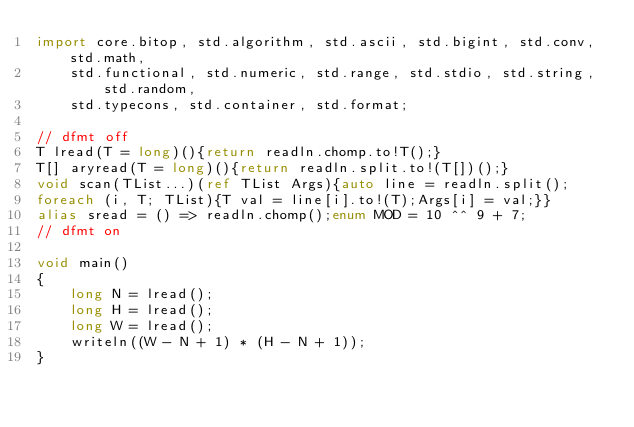<code> <loc_0><loc_0><loc_500><loc_500><_D_>import core.bitop, std.algorithm, std.ascii, std.bigint, std.conv, std.math,
    std.functional, std.numeric, std.range, std.stdio, std.string, std.random,
    std.typecons, std.container, std.format;

// dfmt off
T lread(T = long)(){return readln.chomp.to!T();}
T[] aryread(T = long)(){return readln.split.to!(T[])();}
void scan(TList...)(ref TList Args){auto line = readln.split();
foreach (i, T; TList){T val = line[i].to!(T);Args[i] = val;}}
alias sread = () => readln.chomp();enum MOD = 10 ^^ 9 + 7;
// dfmt on

void main()
{
    long N = lread();
    long H = lread();
    long W = lread();
    writeln((W - N + 1) * (H - N + 1));
}
</code> 